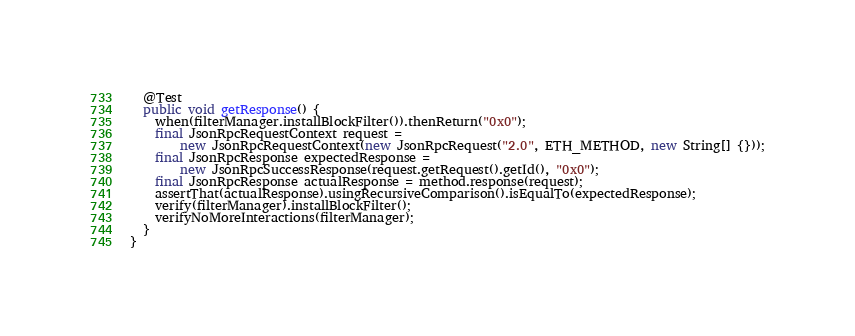Convert code to text. <code><loc_0><loc_0><loc_500><loc_500><_Java_>
  @Test
  public void getResponse() {
    when(filterManager.installBlockFilter()).thenReturn("0x0");
    final JsonRpcRequestContext request =
        new JsonRpcRequestContext(new JsonRpcRequest("2.0", ETH_METHOD, new String[] {}));
    final JsonRpcResponse expectedResponse =
        new JsonRpcSuccessResponse(request.getRequest().getId(), "0x0");
    final JsonRpcResponse actualResponse = method.response(request);
    assertThat(actualResponse).usingRecursiveComparison().isEqualTo(expectedResponse);
    verify(filterManager).installBlockFilter();
    verifyNoMoreInteractions(filterManager);
  }
}
</code> 